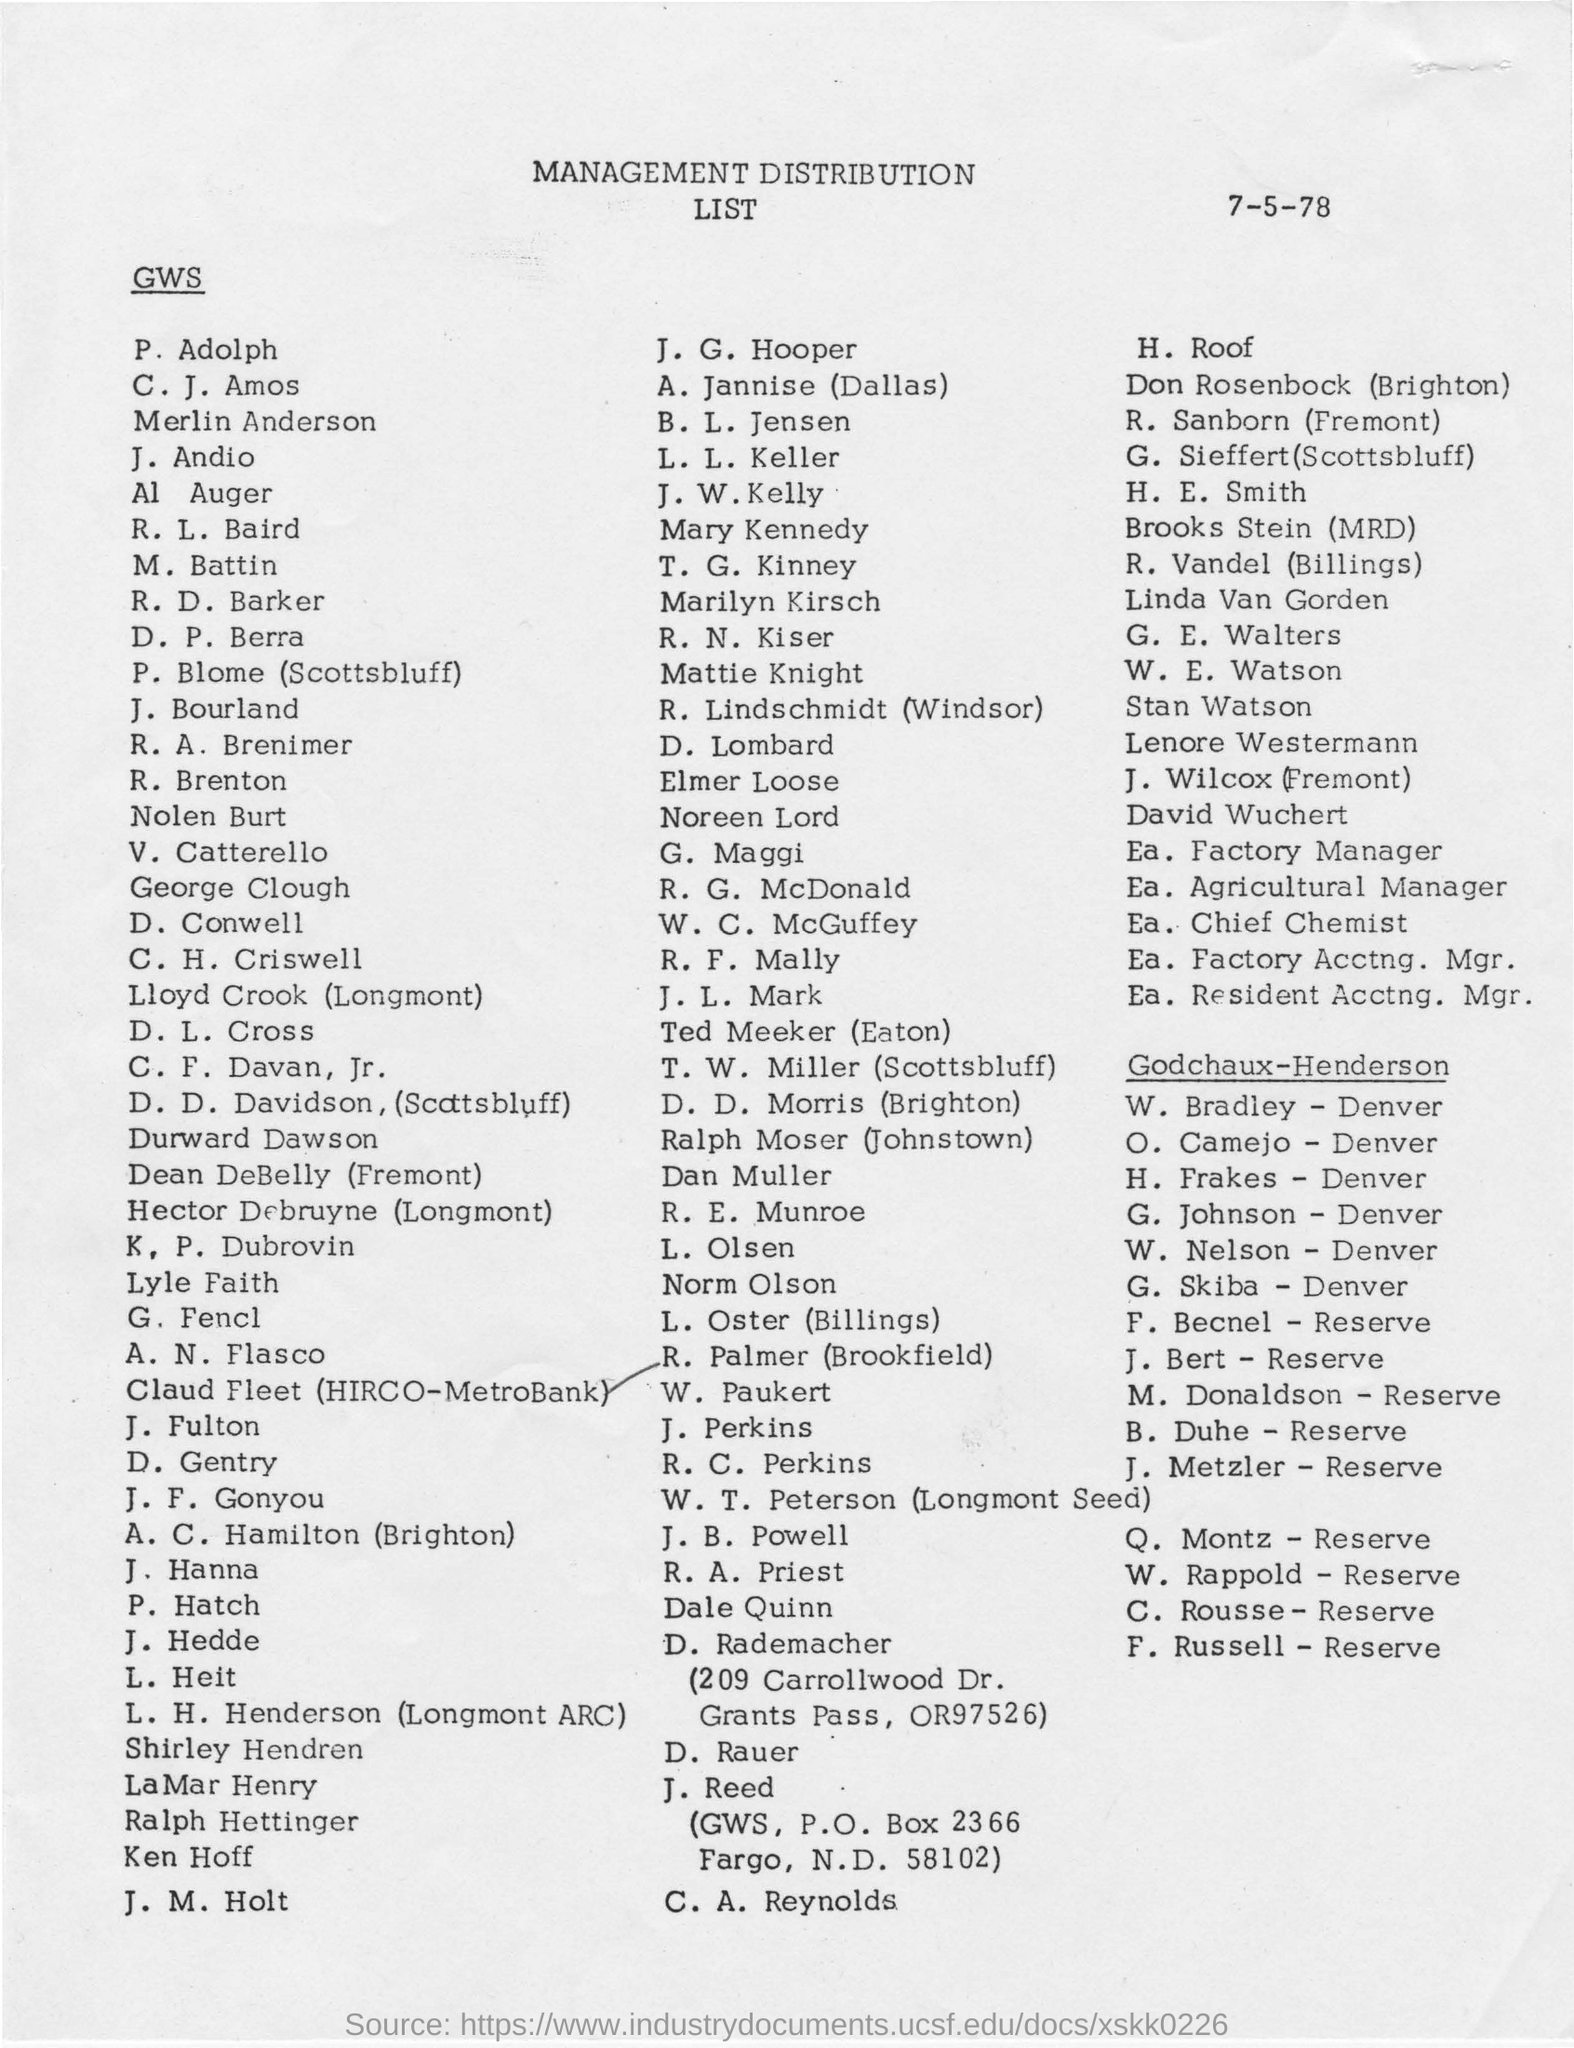Give some essential details in this illustration. The date mentioned in the given page is July 5, 1978. 